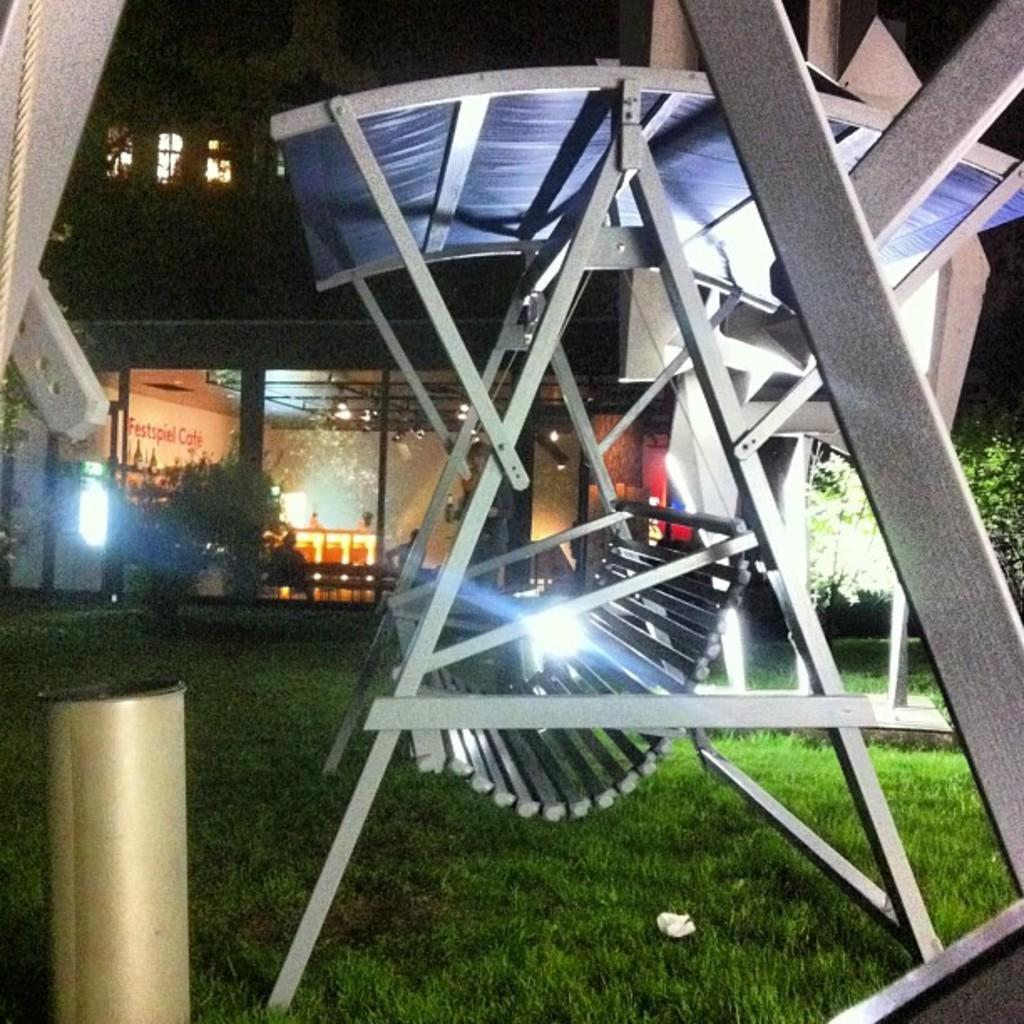How would you summarize this image in a sentence or two? There is a garden swing on the grass. There are trees and a building at the back which has glass walls. 